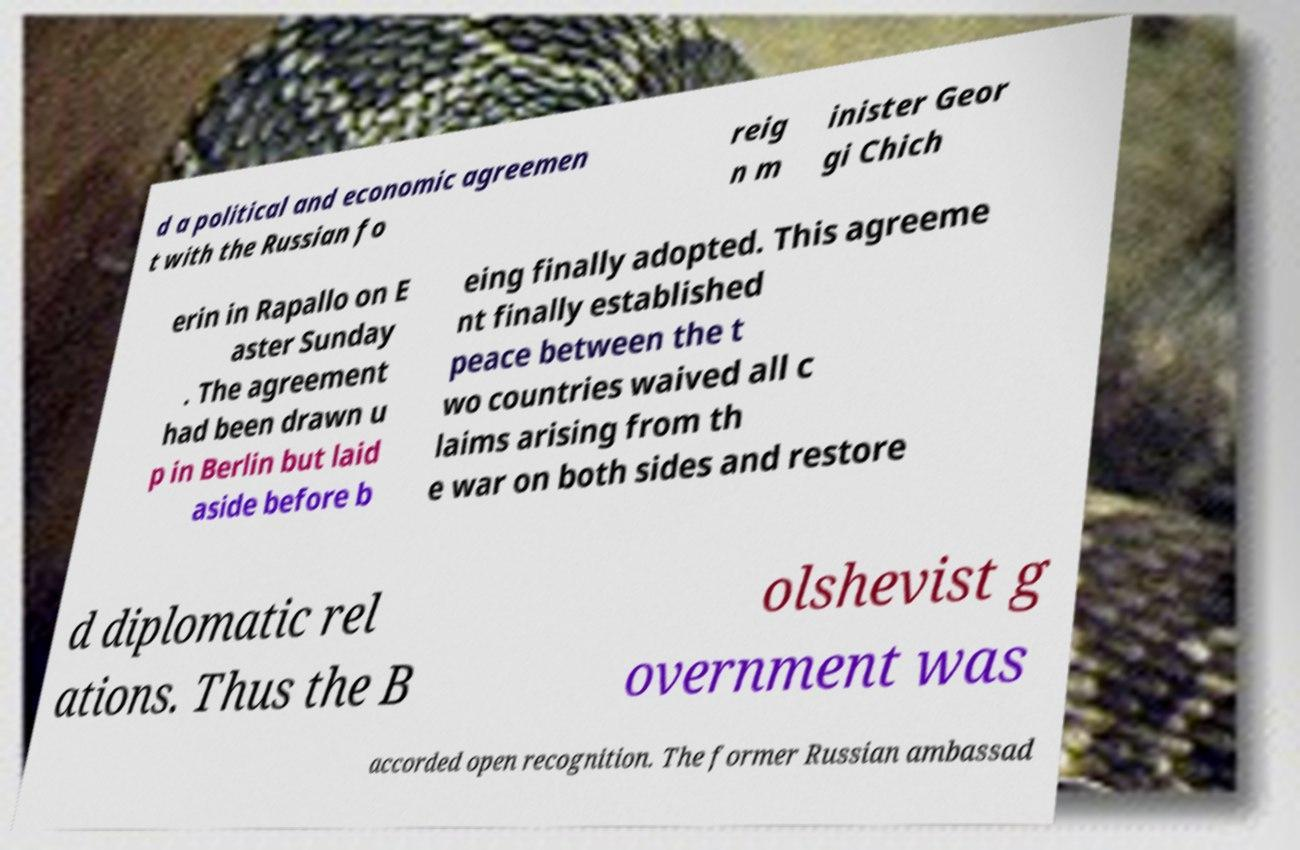Could you assist in decoding the text presented in this image and type it out clearly? d a political and economic agreemen t with the Russian fo reig n m inister Geor gi Chich erin in Rapallo on E aster Sunday . The agreement had been drawn u p in Berlin but laid aside before b eing finally adopted. This agreeme nt finally established peace between the t wo countries waived all c laims arising from th e war on both sides and restore d diplomatic rel ations. Thus the B olshevist g overnment was accorded open recognition. The former Russian ambassad 